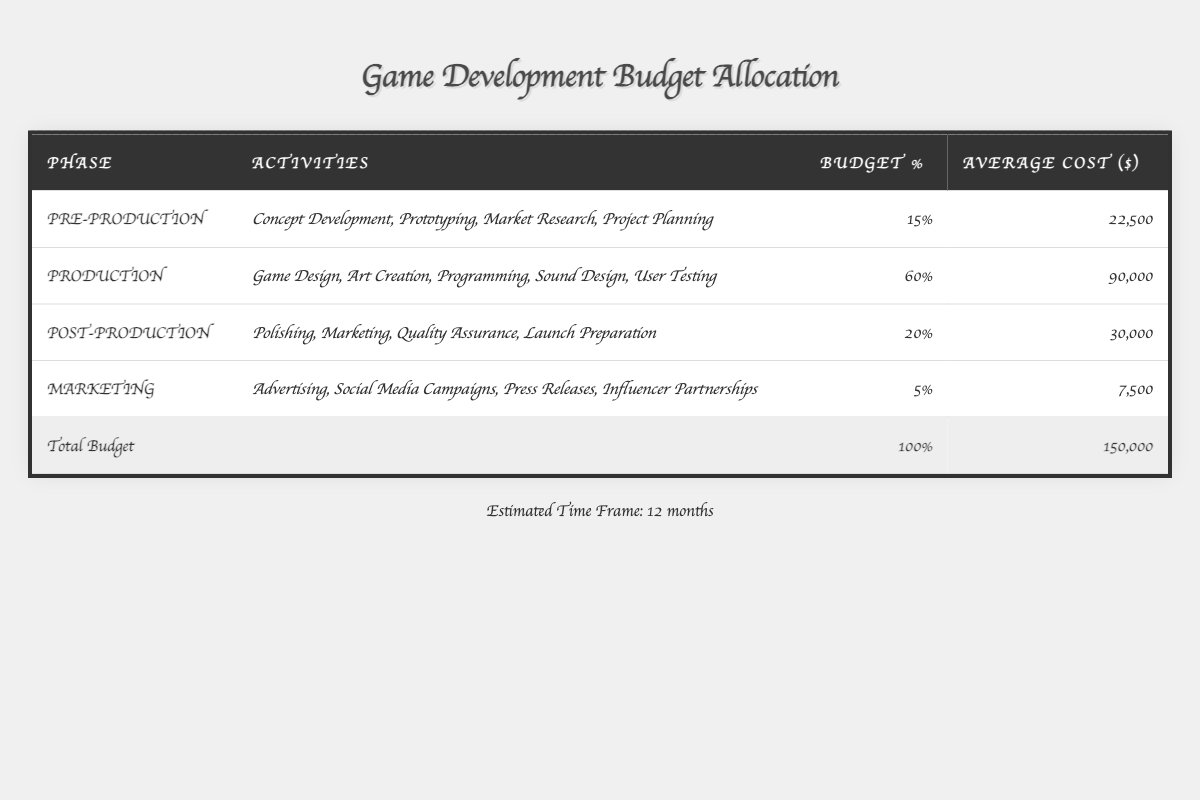What is the budget percentage allocated to the Production phase? The table shows that the Production phase has a budget percentage of 60% listed directly in the corresponding row.
Answer: 60% How much does the Marketing phase cost on average? The table specifies that the average cost for the Marketing phase is $7,500, directly from the relevant cell in the table.
Answer: 7,500 What is the total budget allocated for all phases of game development? The last row of the table indicates that the total budget for all phases is $150,000.
Answer: 150,000 Which phase has the highest budget allocation percentage? By looking at the budget percentages in the table, Production at 60% has the highest percentage compared to Pre-production (15%), Post-production (20%), and Marketing (5%).
Answer: Production What is the combined average cost of Pre-production and Post-production? The average cost of Pre-production is $22,500 and Post-production is $30,000; sum = 22,500 + 30,000 = 52,500.
Answer: 52,500 Is the average cost of all phases more than $70,000? The total budget is $150,000 for four phases; dividing $150,000 by 4 gives $37,500 on average, which is less than $70,000.
Answer: No How much more is allocated to the Production phase compared to the Marketing phase? The Production phase costs $90,000 and the Marketing phase costs $7,500; therefore, $90,000 - $7,500 = $82,500 more.
Answer: 82,500 What percentage of the overall budget is spent on Marketing activities? The table denotes that Marketing activities account for 5% of the total budget, directly stated in the Marketing row.
Answer: 5% What is the ratio of the budget allocation for Post-production to Pre-production? Post-production is allocated 20% and Pre-production is allocated 15%; thus, the ratio is 20:15, which simplifies to 4:3.
Answer: 4:3 If the Production phase was cut in half, what would the new budget for that phase be? The original average cost for Production is $90,000; cutting this in half gives $90,000 / 2 = $45,000.
Answer: 45,000 